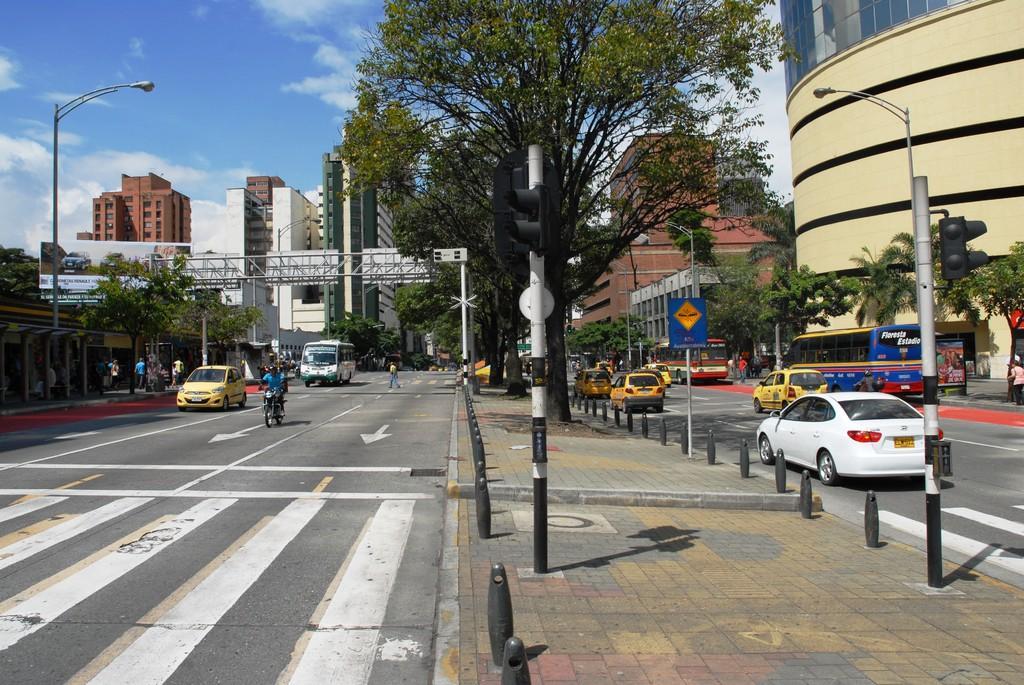Could you give a brief overview of what you see in this image? In this image a person is riding a bike on the road. There are few vehicles on the road. A person is crossing the road. Left side few persons are walking on the pavement having street lights and few trees on it. Over the road there is a metal arch. Right side there are few vehicles on the road. Beside there is a pavement having few poles, trees. On the pavement there are poles having traffic lights attached to it. Right side few persons are walking on the pavement having few trees on it. Background there are few buildings. Top of the image there is sky with some clouds. 